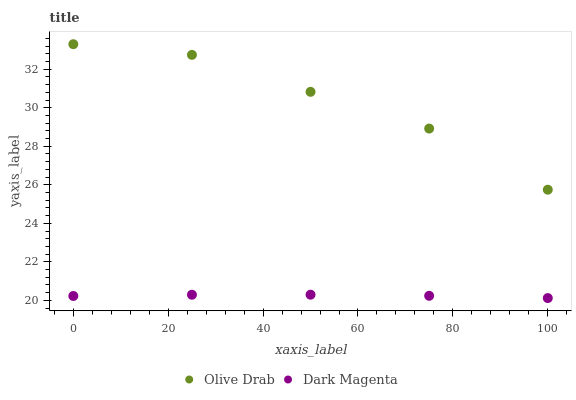Does Dark Magenta have the minimum area under the curve?
Answer yes or no. Yes. Does Olive Drab have the maximum area under the curve?
Answer yes or no. Yes. Does Olive Drab have the minimum area under the curve?
Answer yes or no. No. Is Dark Magenta the smoothest?
Answer yes or no. Yes. Is Olive Drab the roughest?
Answer yes or no. Yes. Is Olive Drab the smoothest?
Answer yes or no. No. Does Dark Magenta have the lowest value?
Answer yes or no. Yes. Does Olive Drab have the lowest value?
Answer yes or no. No. Does Olive Drab have the highest value?
Answer yes or no. Yes. Is Dark Magenta less than Olive Drab?
Answer yes or no. Yes. Is Olive Drab greater than Dark Magenta?
Answer yes or no. Yes. Does Dark Magenta intersect Olive Drab?
Answer yes or no. No. 